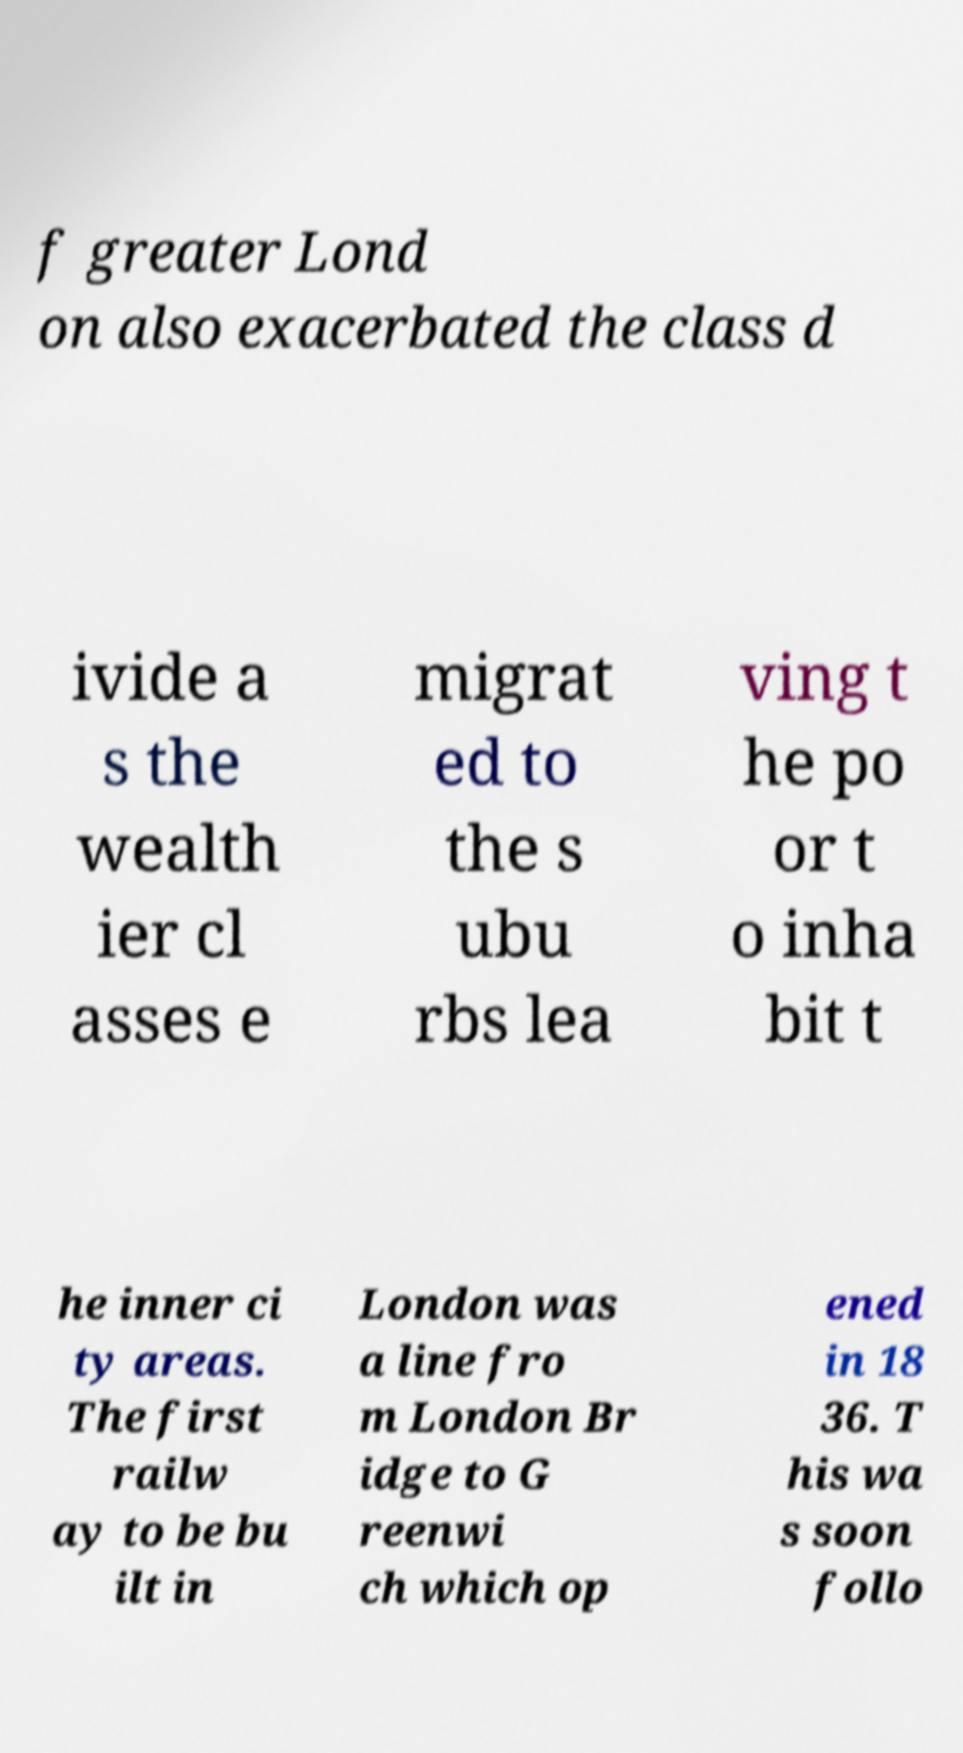What messages or text are displayed in this image? I need them in a readable, typed format. f greater Lond on also exacerbated the class d ivide a s the wealth ier cl asses e migrat ed to the s ubu rbs lea ving t he po or t o inha bit t he inner ci ty areas. The first railw ay to be bu ilt in London was a line fro m London Br idge to G reenwi ch which op ened in 18 36. T his wa s soon follo 